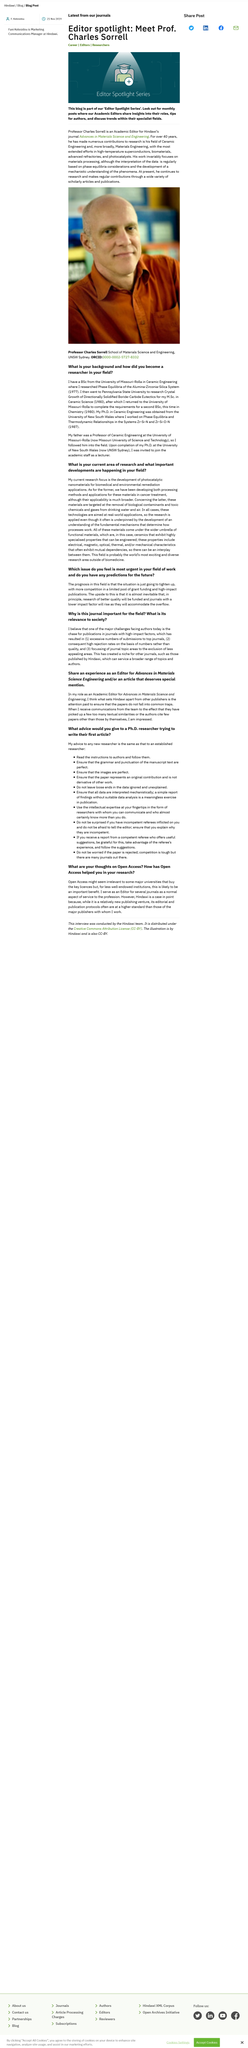Give some essential details in this illustration. The Editor Spotlight Series provides insights into the roles and responsibilities of editors, offers tips for authors, and discusses trends within their specialist fields, providing valuable information for anyone interested in the field of publishing. Functional materials possess specialized properties that are characterized by electrical, magnetic, optical, thermal, and/or mechanical characteristics. I always show gratitude towards competent referees by utilizing their experience and implementing their recommendations. The informational sentence can be rephrased as follows:
"His father was not a Professor of Chemical Engineering, but rather a Professor of Ceramic Engineering. The major challenge facing authors is... 